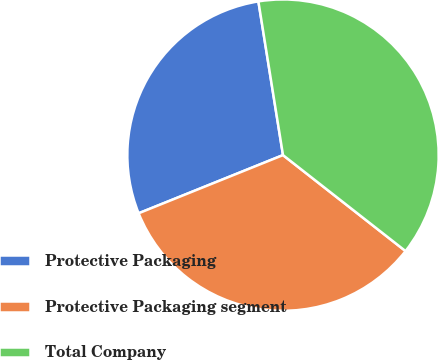Convert chart to OTSL. <chart><loc_0><loc_0><loc_500><loc_500><pie_chart><fcel>Protective Packaging<fcel>Protective Packaging segment<fcel>Total Company<nl><fcel>28.57%<fcel>33.33%<fcel>38.1%<nl></chart> 